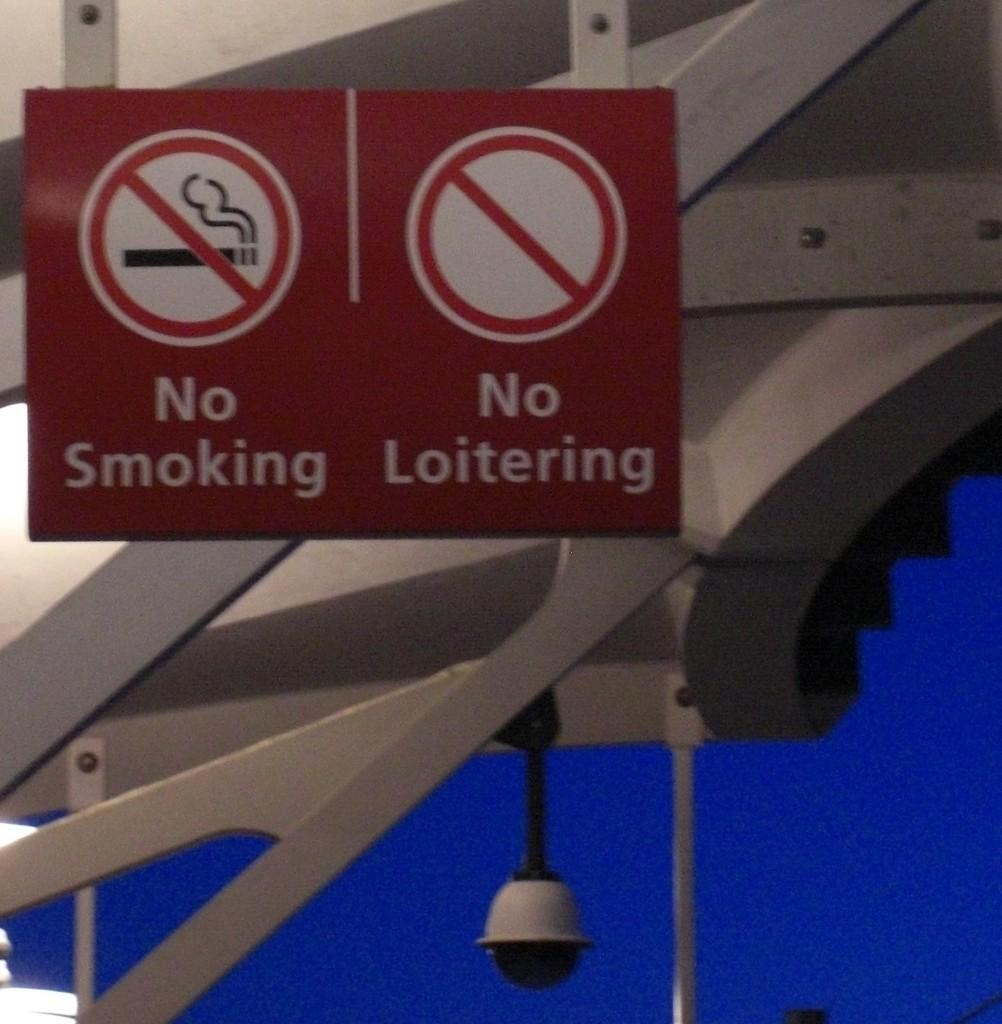<image>
Relay a brief, clear account of the picture shown. A sign hanging displaying No Smoking and No Loitering 